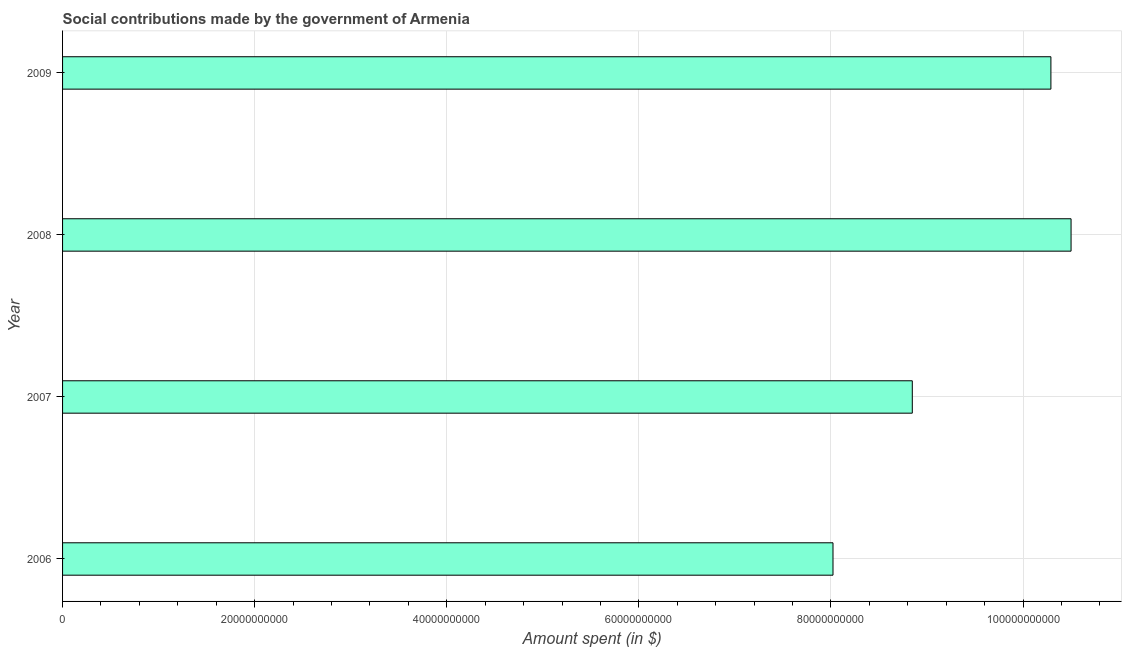What is the title of the graph?
Your answer should be compact. Social contributions made by the government of Armenia. What is the label or title of the X-axis?
Offer a very short reply. Amount spent (in $). What is the amount spent in making social contributions in 2009?
Offer a terse response. 1.03e+11. Across all years, what is the maximum amount spent in making social contributions?
Provide a succinct answer. 1.05e+11. Across all years, what is the minimum amount spent in making social contributions?
Your answer should be very brief. 8.02e+1. In which year was the amount spent in making social contributions minimum?
Offer a terse response. 2006. What is the sum of the amount spent in making social contributions?
Your response must be concise. 3.77e+11. What is the difference between the amount spent in making social contributions in 2006 and 2007?
Keep it short and to the point. -8.26e+09. What is the average amount spent in making social contributions per year?
Offer a terse response. 9.41e+1. What is the median amount spent in making social contributions?
Ensure brevity in your answer.  9.57e+1. In how many years, is the amount spent in making social contributions greater than 92000000000 $?
Provide a short and direct response. 2. Do a majority of the years between 2008 and 2006 (inclusive) have amount spent in making social contributions greater than 44000000000 $?
Keep it short and to the point. Yes. What is the ratio of the amount spent in making social contributions in 2007 to that in 2009?
Provide a succinct answer. 0.86. Is the amount spent in making social contributions in 2006 less than that in 2009?
Provide a short and direct response. Yes. What is the difference between the highest and the second highest amount spent in making social contributions?
Your answer should be very brief. 2.10e+09. What is the difference between the highest and the lowest amount spent in making social contributions?
Your answer should be very brief. 2.48e+1. In how many years, is the amount spent in making social contributions greater than the average amount spent in making social contributions taken over all years?
Provide a short and direct response. 2. How many bars are there?
Your response must be concise. 4. How many years are there in the graph?
Offer a terse response. 4. What is the difference between two consecutive major ticks on the X-axis?
Provide a short and direct response. 2.00e+1. Are the values on the major ticks of X-axis written in scientific E-notation?
Make the answer very short. No. What is the Amount spent (in $) of 2006?
Keep it short and to the point. 8.02e+1. What is the Amount spent (in $) of 2007?
Your answer should be very brief. 8.85e+1. What is the Amount spent (in $) in 2008?
Your answer should be compact. 1.05e+11. What is the Amount spent (in $) of 2009?
Ensure brevity in your answer.  1.03e+11. What is the difference between the Amount spent (in $) in 2006 and 2007?
Offer a very short reply. -8.26e+09. What is the difference between the Amount spent (in $) in 2006 and 2008?
Offer a very short reply. -2.48e+1. What is the difference between the Amount spent (in $) in 2006 and 2009?
Offer a very short reply. -2.27e+1. What is the difference between the Amount spent (in $) in 2007 and 2008?
Provide a short and direct response. -1.65e+1. What is the difference between the Amount spent (in $) in 2007 and 2009?
Your response must be concise. -1.44e+1. What is the difference between the Amount spent (in $) in 2008 and 2009?
Offer a very short reply. 2.10e+09. What is the ratio of the Amount spent (in $) in 2006 to that in 2007?
Make the answer very short. 0.91. What is the ratio of the Amount spent (in $) in 2006 to that in 2008?
Keep it short and to the point. 0.76. What is the ratio of the Amount spent (in $) in 2006 to that in 2009?
Your answer should be compact. 0.78. What is the ratio of the Amount spent (in $) in 2007 to that in 2008?
Your answer should be compact. 0.84. What is the ratio of the Amount spent (in $) in 2007 to that in 2009?
Provide a succinct answer. 0.86. 